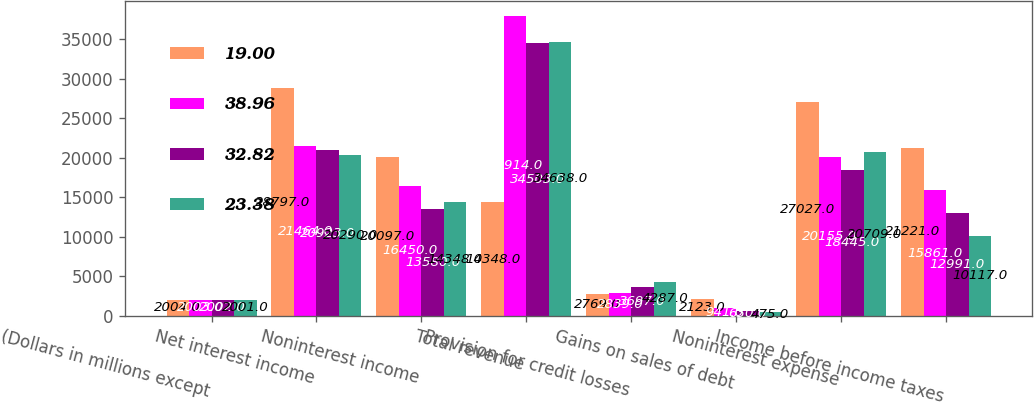<chart> <loc_0><loc_0><loc_500><loc_500><stacked_bar_chart><ecel><fcel>(Dollars in millions except<fcel>Net interest income<fcel>Noninterest income<fcel>Total revenue<fcel>Provision for credit losses<fcel>Gains on sales of debt<fcel>Noninterest expense<fcel>Income before income taxes<nl><fcel>19<fcel>2004<fcel>28797<fcel>20097<fcel>14348<fcel>2769<fcel>2123<fcel>27027<fcel>21221<nl><fcel>38.96<fcel>2003<fcel>21464<fcel>16450<fcel>37914<fcel>2839<fcel>941<fcel>20155<fcel>15861<nl><fcel>32.82<fcel>2002<fcel>20923<fcel>13580<fcel>34503<fcel>3697<fcel>630<fcel>18445<fcel>12991<nl><fcel>23.38<fcel>2001<fcel>20290<fcel>14348<fcel>34638<fcel>4287<fcel>475<fcel>20709<fcel>10117<nl></chart> 